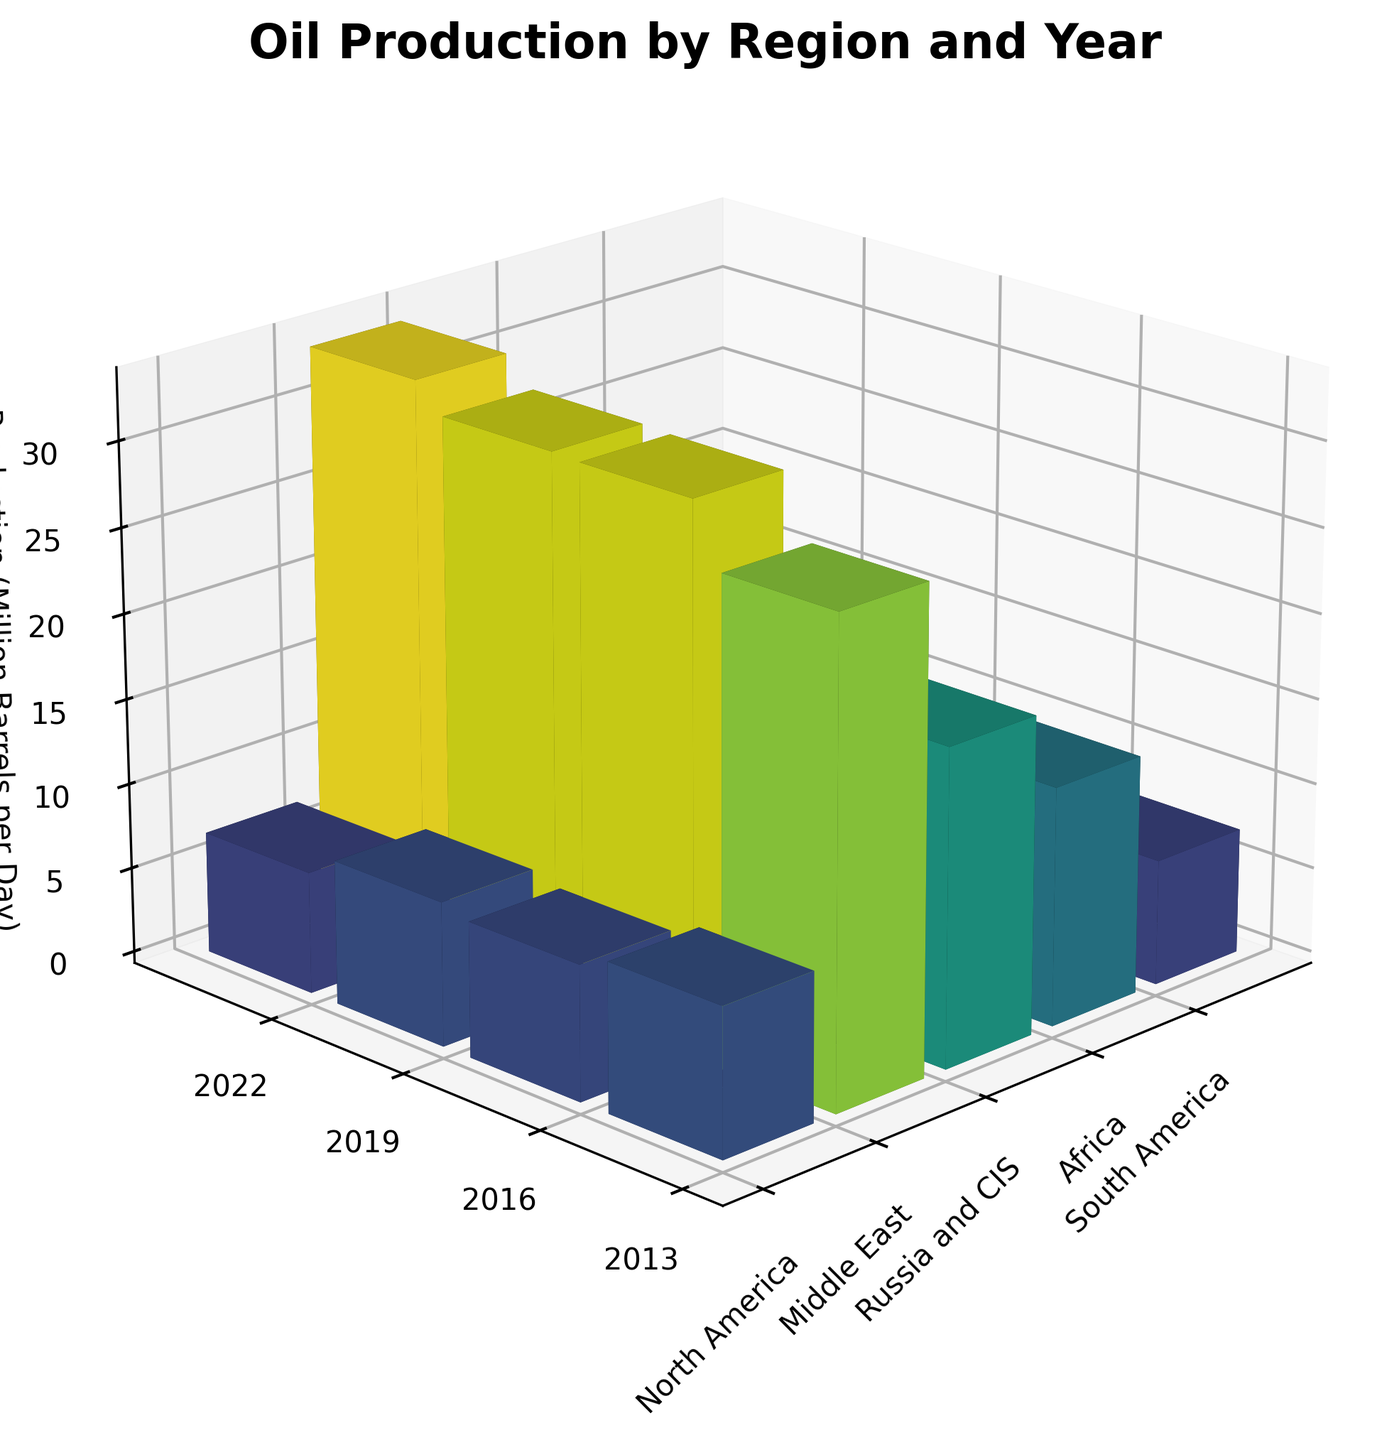What's the title of the figure? The title is usually placed at the top of the figure to give context. Here it indicates what the data represents over time. By looking at the top of the plot, we can read the title.
Answer: Oil Production by Region and Year Which year had the highest oil production in the Middle East? To find this, compare the heights of the bars corresponding to the Middle East across all years. The highest bar represents the year with the maximum production.
Answer: 2022 Which region had the lowest oil production in 2019? Look at all the bars for 2019 and identify the one with the smallest height. This bar indicates the region with the lowest oil production for that year.
Answer: South America What is the difference in oil production between North America and Russia and CIS in 2016? Locate the bars for North America and Russia and CIS in 2016. Subtract the height of the Russia and CIS bar from the height of the North America bar to find the difference.
Answer: 7.1 million barrels per day What is the average oil production in Africa over the given years? Find the heights of the bars representing Africa for all given years (2013, 2016, 2019, 2022). Sum these values and divide by the number of years to get the average.
Answer: 7.8 million barrels per day In which year did North America see its maximum oil production? Examine the heights of the bars corresponding to North America over all years. The year with the tallest bar is the one with maximum production.
Answer: 2019 Which region shows a consistent decrease in oil production over the years? By looking at the pattern of the bars, identify any region where the heights of the bars consistently decrease from 2013 to 2022. This indicates a consistent decrease in production.
Answer: South America How many regions had a production volume between 10 and 20 million barrels per day in 2022? Look at the bars for 2022 and count those whose heights fall within the 10 to 20 million barrels per day range.
Answer: Two regions What's the total oil production in 2013 across all regions? Sum the heights of all the bars for the year 2013 to get the total oil production. This requires adding the values for each region.
Answer: 76.6 million barrels per day Which year experienced the highest overall global oil production? Sum the heights of all the bars for each year and compare these totals. The year with the highest sum represents the highest global production.
Answer: 2022 